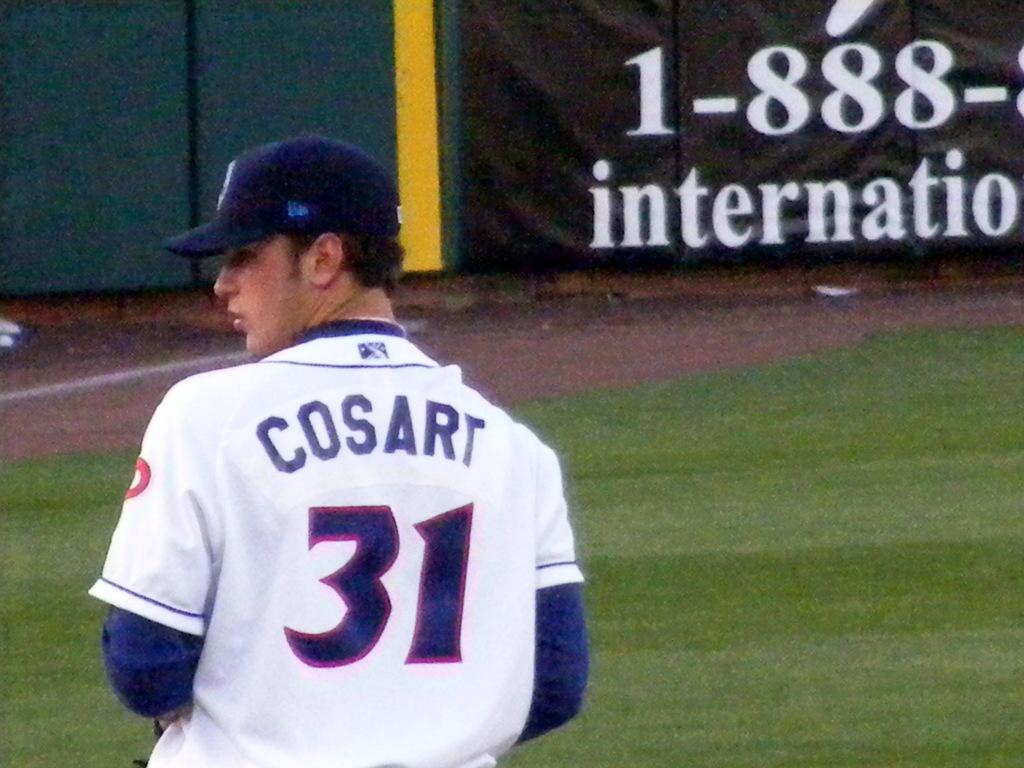What number is this player?
Your answer should be compact. 31. What is the name of the player?
Offer a very short reply. Cosart. 